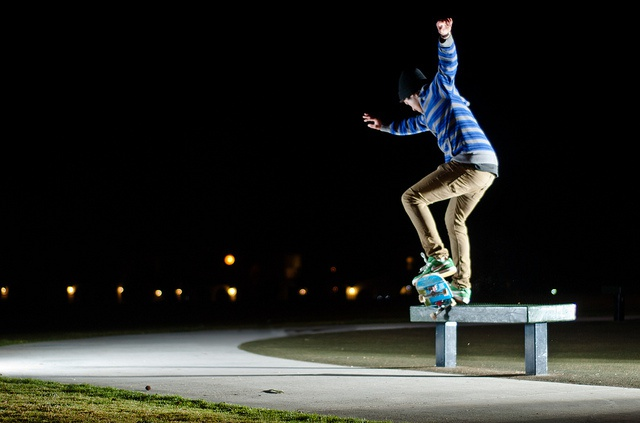Describe the objects in this image and their specific colors. I can see people in black, lightgray, darkgray, and gray tones, bench in black, darkgray, lightgray, teal, and lightblue tones, and skateboard in black, white, lightblue, gray, and darkgray tones in this image. 